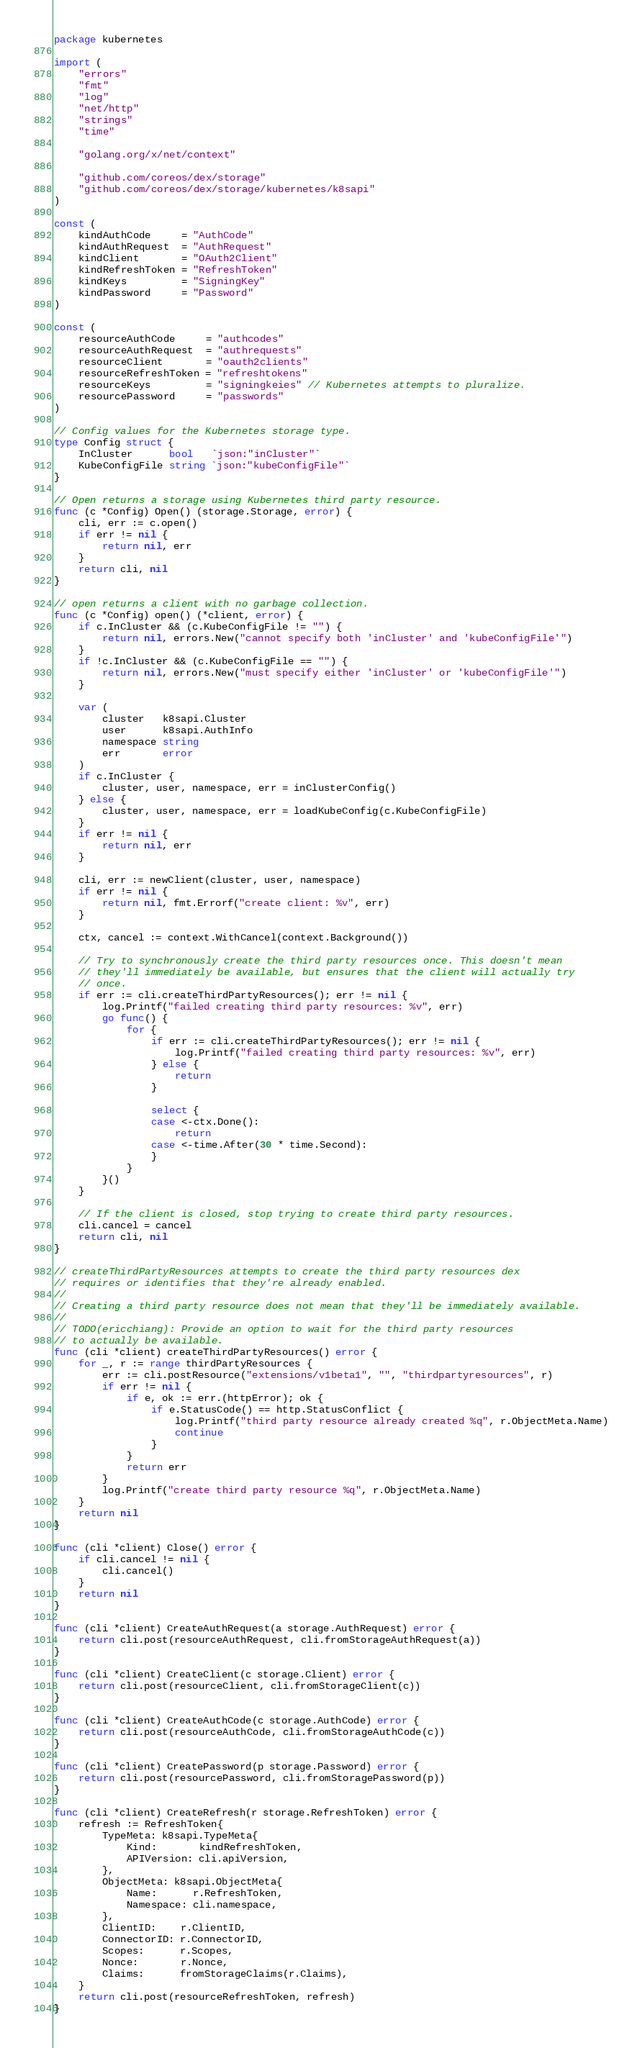<code> <loc_0><loc_0><loc_500><loc_500><_Go_>package kubernetes

import (
	"errors"
	"fmt"
	"log"
	"net/http"
	"strings"
	"time"

	"golang.org/x/net/context"

	"github.com/coreos/dex/storage"
	"github.com/coreos/dex/storage/kubernetes/k8sapi"
)

const (
	kindAuthCode     = "AuthCode"
	kindAuthRequest  = "AuthRequest"
	kindClient       = "OAuth2Client"
	kindRefreshToken = "RefreshToken"
	kindKeys         = "SigningKey"
	kindPassword     = "Password"
)

const (
	resourceAuthCode     = "authcodes"
	resourceAuthRequest  = "authrequests"
	resourceClient       = "oauth2clients"
	resourceRefreshToken = "refreshtokens"
	resourceKeys         = "signingkeies" // Kubernetes attempts to pluralize.
	resourcePassword     = "passwords"
)

// Config values for the Kubernetes storage type.
type Config struct {
	InCluster      bool   `json:"inCluster"`
	KubeConfigFile string `json:"kubeConfigFile"`
}

// Open returns a storage using Kubernetes third party resource.
func (c *Config) Open() (storage.Storage, error) {
	cli, err := c.open()
	if err != nil {
		return nil, err
	}
	return cli, nil
}

// open returns a client with no garbage collection.
func (c *Config) open() (*client, error) {
	if c.InCluster && (c.KubeConfigFile != "") {
		return nil, errors.New("cannot specify both 'inCluster' and 'kubeConfigFile'")
	}
	if !c.InCluster && (c.KubeConfigFile == "") {
		return nil, errors.New("must specify either 'inCluster' or 'kubeConfigFile'")
	}

	var (
		cluster   k8sapi.Cluster
		user      k8sapi.AuthInfo
		namespace string
		err       error
	)
	if c.InCluster {
		cluster, user, namespace, err = inClusterConfig()
	} else {
		cluster, user, namespace, err = loadKubeConfig(c.KubeConfigFile)
	}
	if err != nil {
		return nil, err
	}

	cli, err := newClient(cluster, user, namespace)
	if err != nil {
		return nil, fmt.Errorf("create client: %v", err)
	}

	ctx, cancel := context.WithCancel(context.Background())

	// Try to synchronously create the third party resources once. This doesn't mean
	// they'll immediately be available, but ensures that the client will actually try
	// once.
	if err := cli.createThirdPartyResources(); err != nil {
		log.Printf("failed creating third party resources: %v", err)
		go func() {
			for {
				if err := cli.createThirdPartyResources(); err != nil {
					log.Printf("failed creating third party resources: %v", err)
				} else {
					return
				}

				select {
				case <-ctx.Done():
					return
				case <-time.After(30 * time.Second):
				}
			}
		}()
	}

	// If the client is closed, stop trying to create third party resources.
	cli.cancel = cancel
	return cli, nil
}

// createThirdPartyResources attempts to create the third party resources dex
// requires or identifies that they're already enabled.
//
// Creating a third party resource does not mean that they'll be immediately available.
//
// TODO(ericchiang): Provide an option to wait for the third party resources
// to actually be available.
func (cli *client) createThirdPartyResources() error {
	for _, r := range thirdPartyResources {
		err := cli.postResource("extensions/v1beta1", "", "thirdpartyresources", r)
		if err != nil {
			if e, ok := err.(httpError); ok {
				if e.StatusCode() == http.StatusConflict {
					log.Printf("third party resource already created %q", r.ObjectMeta.Name)
					continue
				}
			}
			return err
		}
		log.Printf("create third party resource %q", r.ObjectMeta.Name)
	}
	return nil
}

func (cli *client) Close() error {
	if cli.cancel != nil {
		cli.cancel()
	}
	return nil
}

func (cli *client) CreateAuthRequest(a storage.AuthRequest) error {
	return cli.post(resourceAuthRequest, cli.fromStorageAuthRequest(a))
}

func (cli *client) CreateClient(c storage.Client) error {
	return cli.post(resourceClient, cli.fromStorageClient(c))
}

func (cli *client) CreateAuthCode(c storage.AuthCode) error {
	return cli.post(resourceAuthCode, cli.fromStorageAuthCode(c))
}

func (cli *client) CreatePassword(p storage.Password) error {
	return cli.post(resourcePassword, cli.fromStoragePassword(p))
}

func (cli *client) CreateRefresh(r storage.RefreshToken) error {
	refresh := RefreshToken{
		TypeMeta: k8sapi.TypeMeta{
			Kind:       kindRefreshToken,
			APIVersion: cli.apiVersion,
		},
		ObjectMeta: k8sapi.ObjectMeta{
			Name:      r.RefreshToken,
			Namespace: cli.namespace,
		},
		ClientID:    r.ClientID,
		ConnectorID: r.ConnectorID,
		Scopes:      r.Scopes,
		Nonce:       r.Nonce,
		Claims:      fromStorageClaims(r.Claims),
	}
	return cli.post(resourceRefreshToken, refresh)
}
</code> 